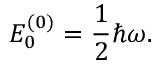Convert formula to latex. <formula><loc_0><loc_0><loc_500><loc_500>E _ { 0 } ^ { ( 0 ) } = { \frac { 1 } { 2 } } \hbar { \omega } .</formula> 